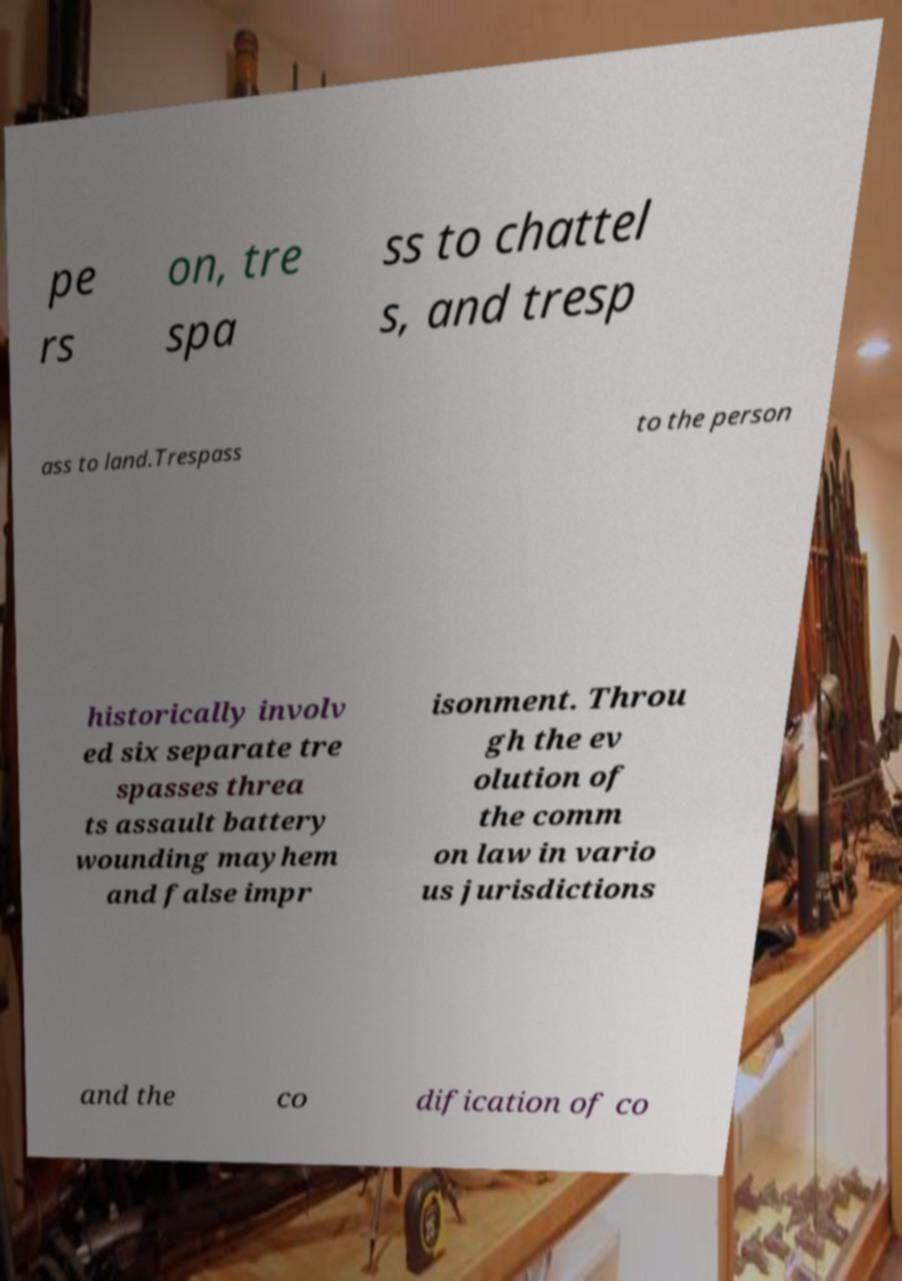Could you extract and type out the text from this image? pe rs on, tre spa ss to chattel s, and tresp ass to land.Trespass to the person historically involv ed six separate tre spasses threa ts assault battery wounding mayhem and false impr isonment. Throu gh the ev olution of the comm on law in vario us jurisdictions and the co dification of co 